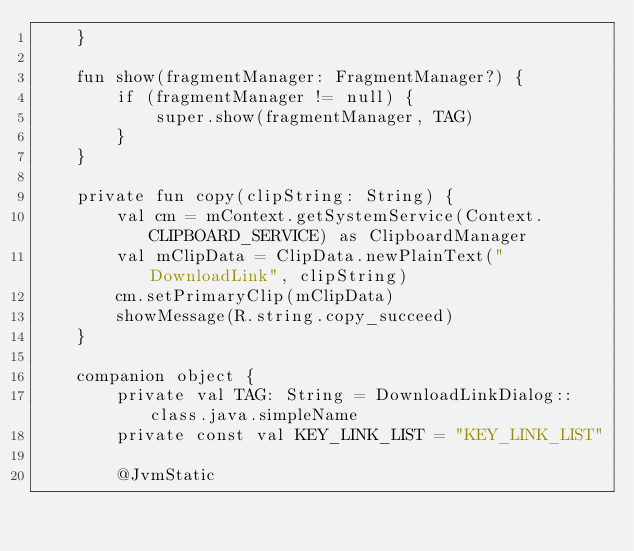Convert code to text. <code><loc_0><loc_0><loc_500><loc_500><_Kotlin_>    }

    fun show(fragmentManager: FragmentManager?) {
        if (fragmentManager != null) {
            super.show(fragmentManager, TAG)
        }
    }

    private fun copy(clipString: String) {
        val cm = mContext.getSystemService(Context.CLIPBOARD_SERVICE) as ClipboardManager
        val mClipData = ClipData.newPlainText("DownloadLink", clipString)
        cm.setPrimaryClip(mClipData)
        showMessage(R.string.copy_succeed)
    }

    companion object {
        private val TAG: String = DownloadLinkDialog::class.java.simpleName
        private const val KEY_LINK_LIST = "KEY_LINK_LIST"

        @JvmStatic</code> 